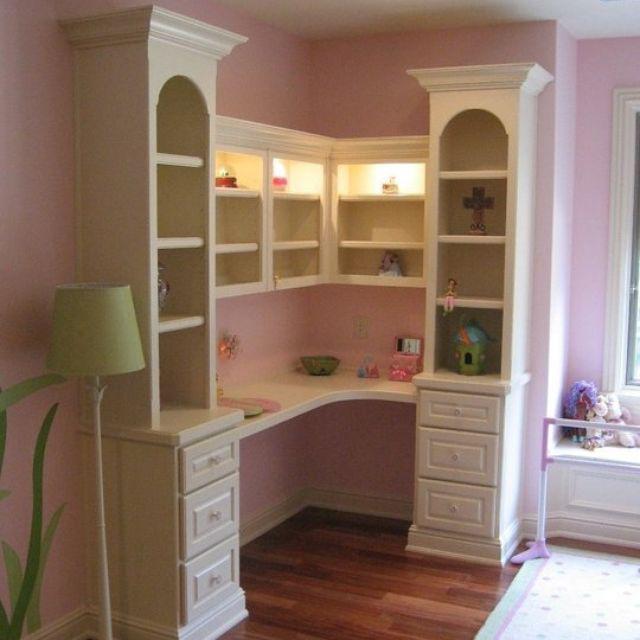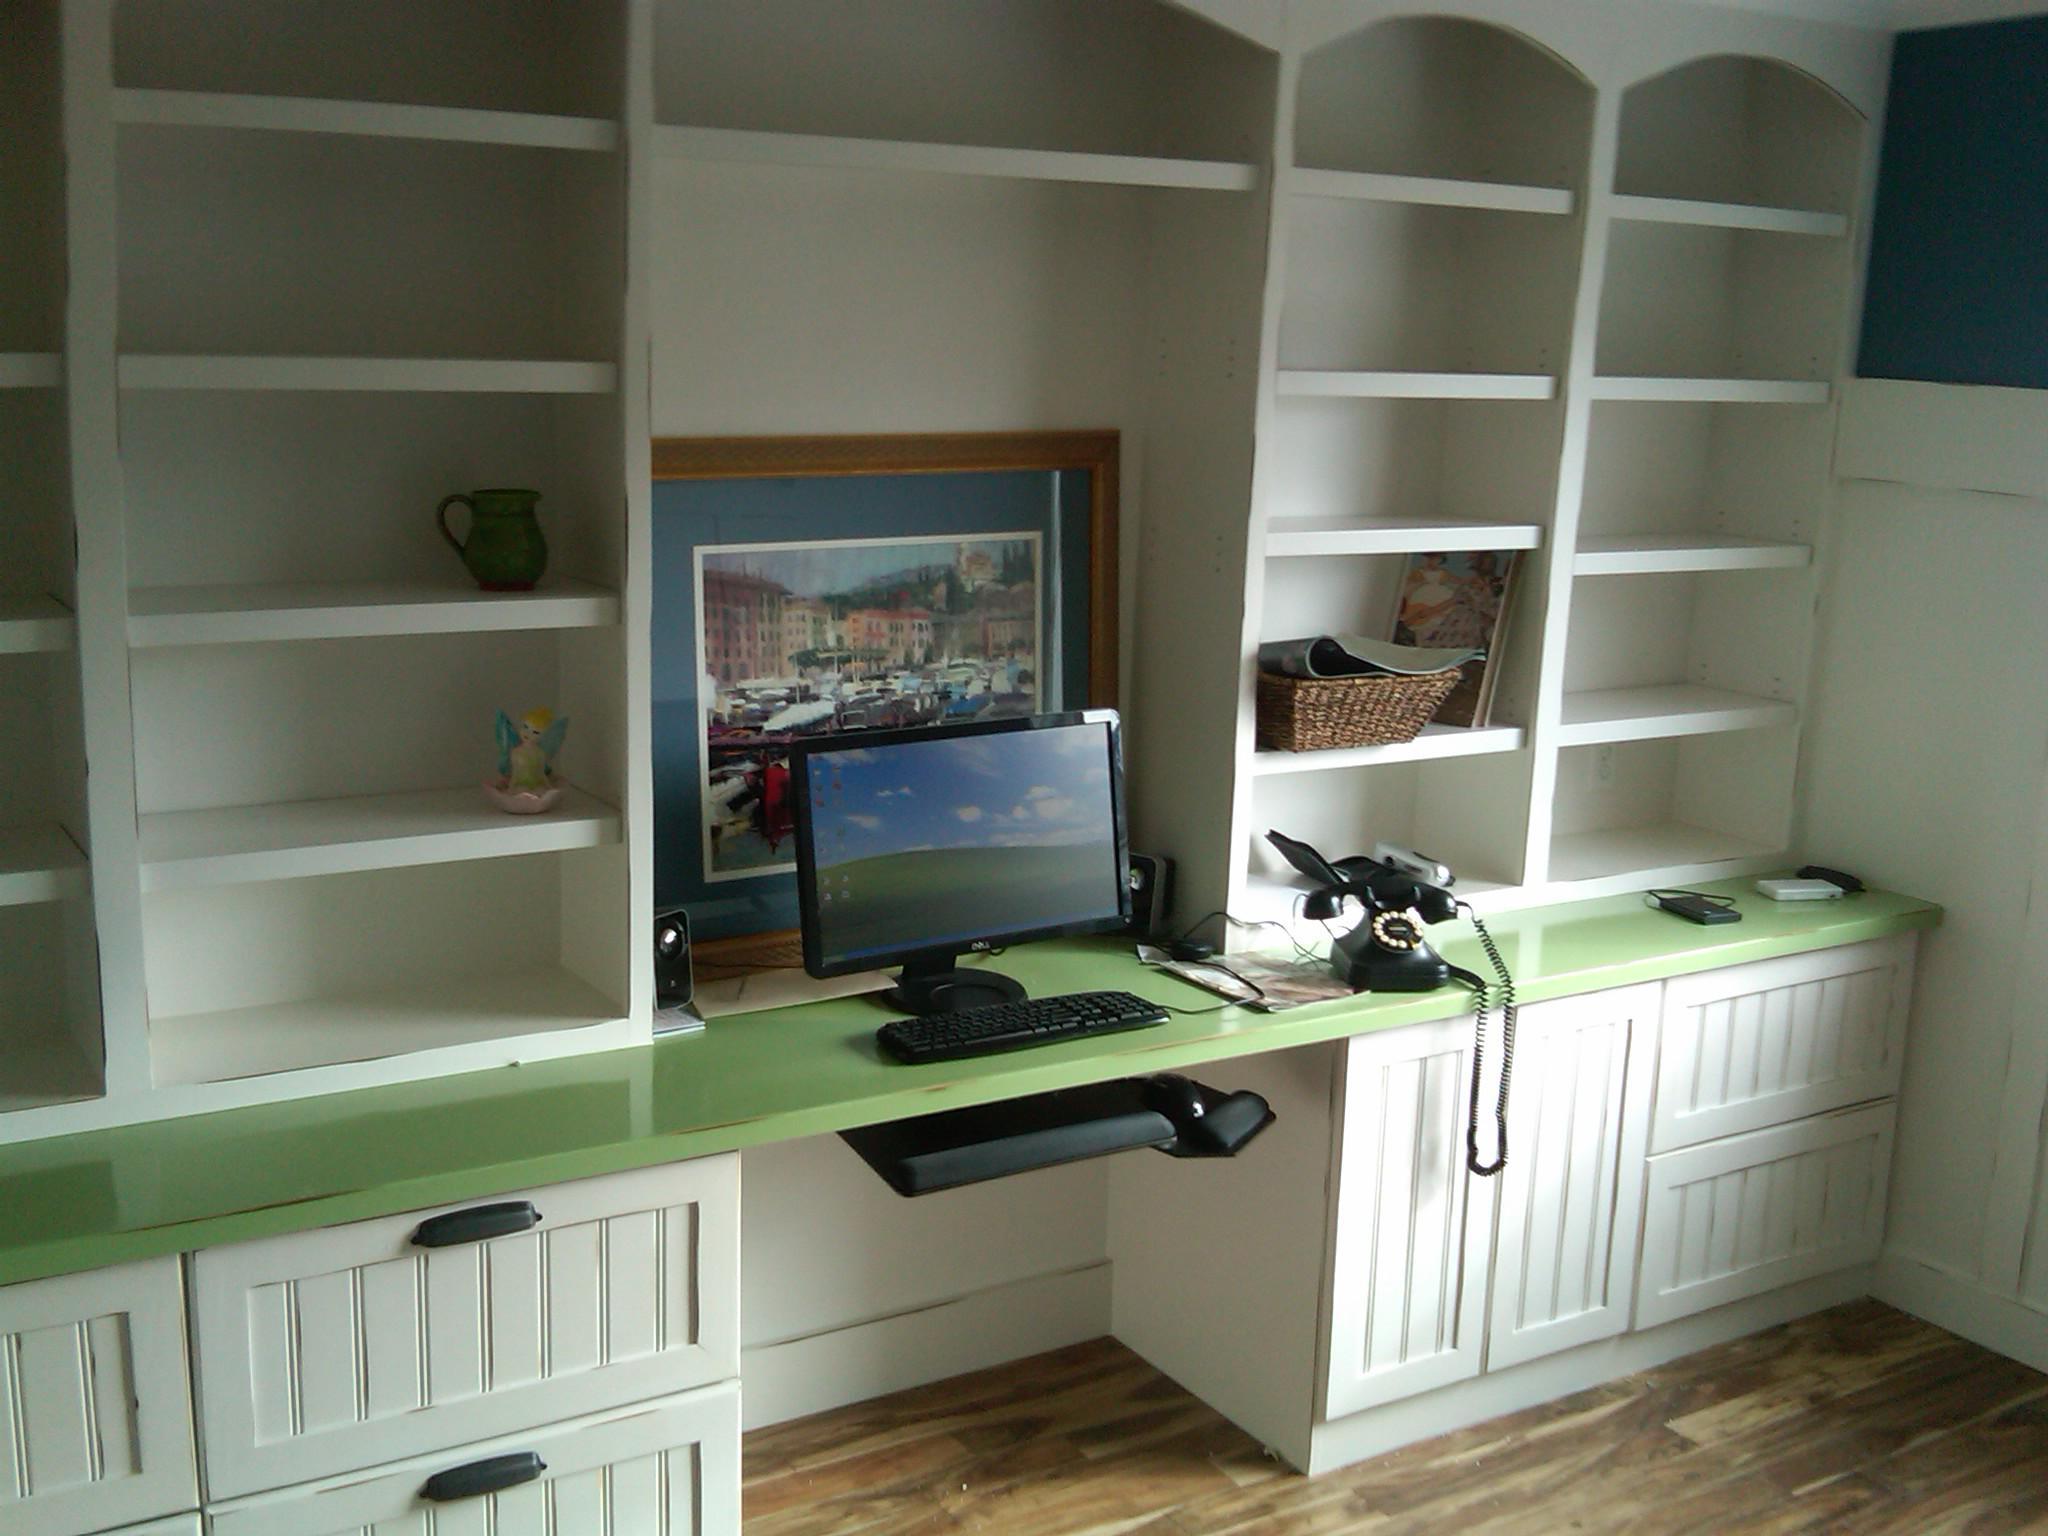The first image is the image on the left, the second image is the image on the right. Given the left and right images, does the statement "An image shows a chair pulled up to a white desk, which sits under a wall-mounted white shelf unit." hold true? Answer yes or no. No. The first image is the image on the left, the second image is the image on the right. For the images shown, is this caption "In one image, a center desk space has two open upper shelving units on each side with corresponding closed units below." true? Answer yes or no. Yes. 